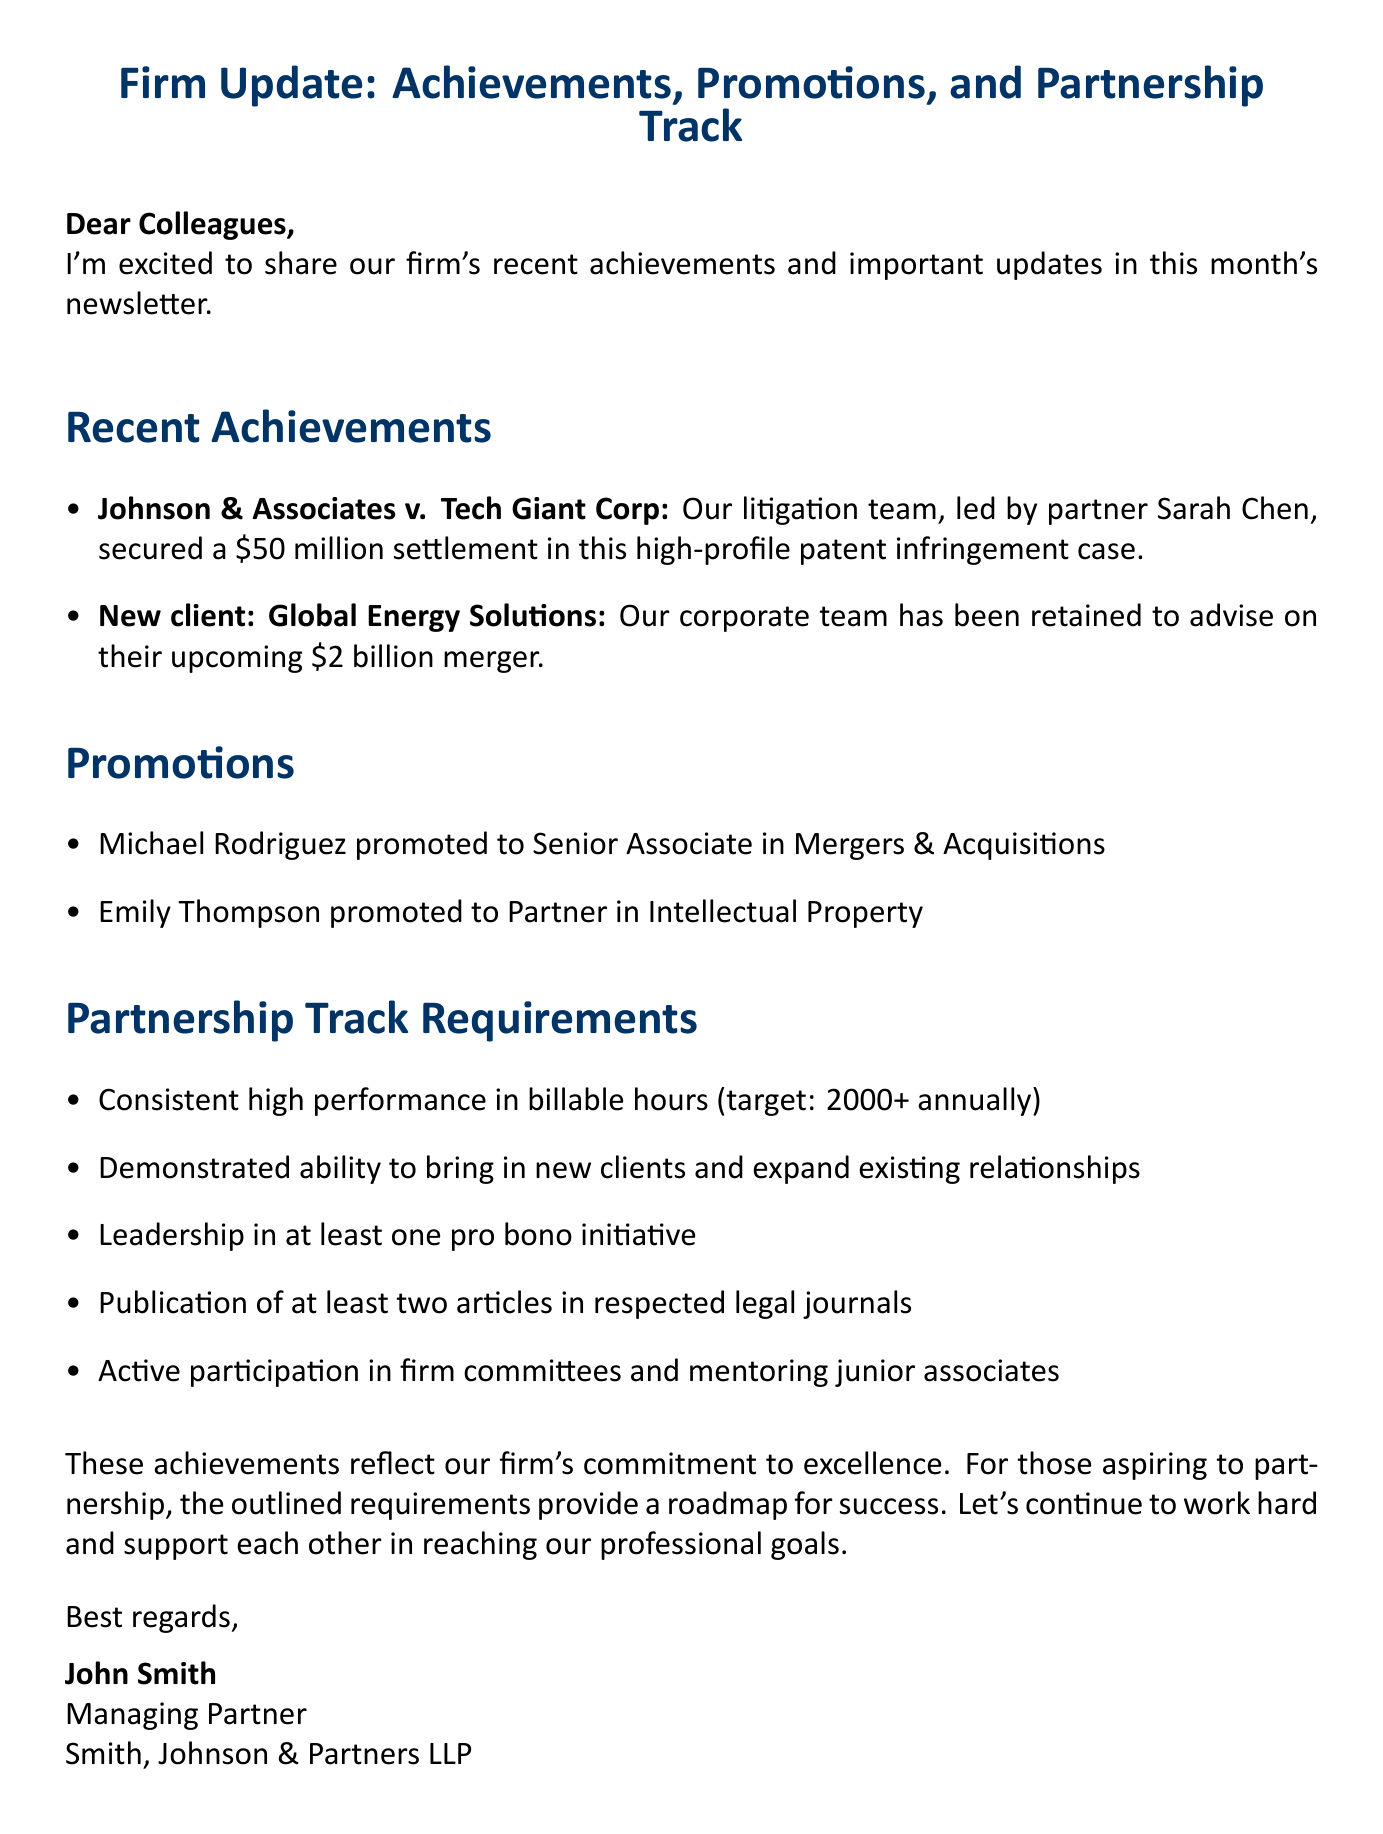What is the subject of the email? The subject is provided at the beginning of the email and summarizes its main focus on achievements and partnership track.
Answer: Firm Update: Achievements, Promotions, and Partnership Track Who secured a $50 million settlement? This information is found in the recent achievements section, identifying the attorney involved in the case.
Answer: Sarah Chen What is Michael Rodriguez's new position? This question refers to the promotions section, where the new positions are listed.
Answer: Senior Associate How many articles must be published to meet the partnership track requirement? This information comes from the partnership track requirements, specifying the number of articles needed.
Answer: Two In which practice is Emily Thompson now a partner? This is detail from the promotions section, indicating the practice area for the promoted partner.
Answer: Intellectual Property What is the target for annual billable hours? This is a specific requirement mentioned in the partnership track requirements section.
Answer: 2000+ Which team is advising Global Energy Solutions? This question seeks to identify the team involved with the new client acquisition mentioned in the recent achievements.
Answer: Corporate team What is the primary purpose of the email? The purpose is stated in the introduction of the document, focusing on updates.
Answer: Share achievements and important updates 